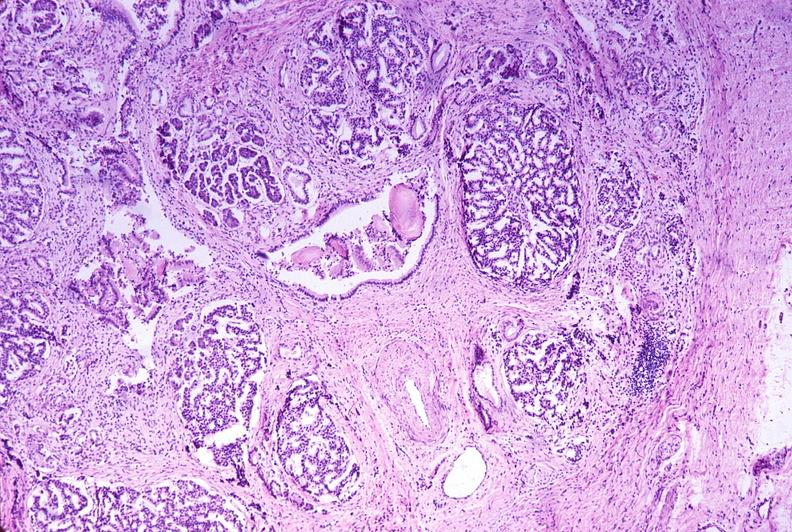what does this image show?
Answer the question using a single word or phrase. Chronic pancreatitis 